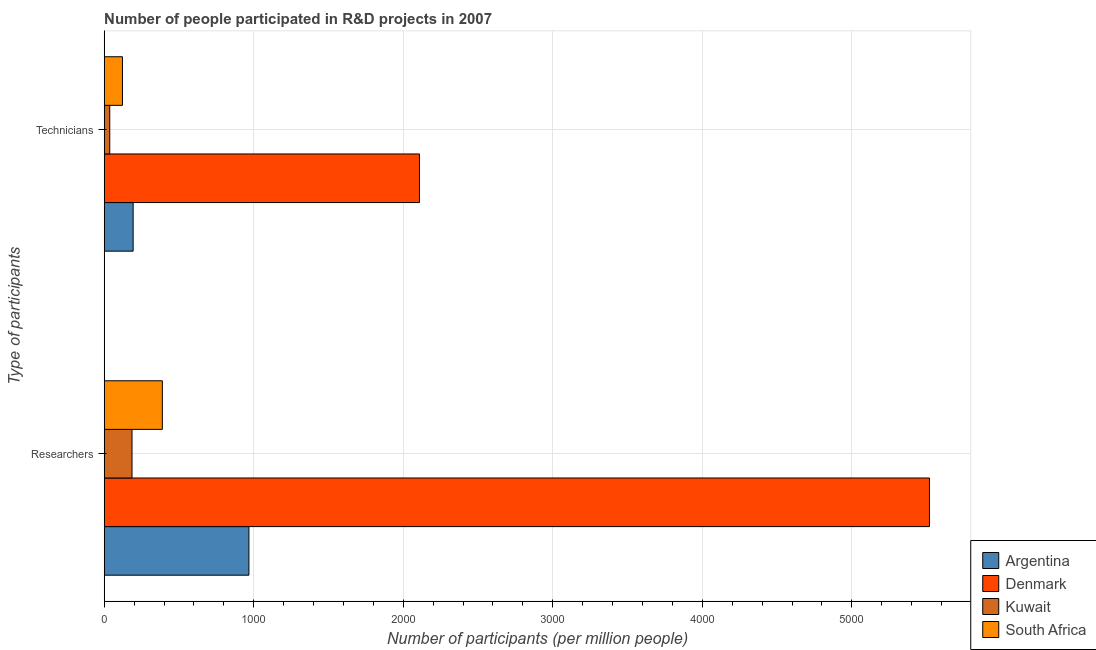How many groups of bars are there?
Your answer should be compact. 2. Are the number of bars per tick equal to the number of legend labels?
Your response must be concise. Yes. How many bars are there on the 2nd tick from the bottom?
Provide a short and direct response. 4. What is the label of the 2nd group of bars from the top?
Your answer should be compact. Researchers. What is the number of technicians in South Africa?
Make the answer very short. 121.96. Across all countries, what is the maximum number of technicians?
Your answer should be compact. 2108.42. Across all countries, what is the minimum number of researchers?
Provide a succinct answer. 185.93. In which country was the number of technicians minimum?
Offer a terse response. Kuwait. What is the total number of researchers in the graph?
Your answer should be compact. 7061.79. What is the difference between the number of researchers in South Africa and that in Kuwait?
Your response must be concise. 202.86. What is the difference between the number of researchers in Argentina and the number of technicians in South Africa?
Provide a short and direct response. 845.8. What is the average number of researchers per country?
Your response must be concise. 1765.45. What is the difference between the number of researchers and number of technicians in Denmark?
Keep it short and to the point. 3410.89. In how many countries, is the number of researchers greater than 3800 ?
Offer a very short reply. 1. What is the ratio of the number of researchers in Denmark to that in South Africa?
Your response must be concise. 14.2. In how many countries, is the number of researchers greater than the average number of researchers taken over all countries?
Your answer should be compact. 1. What does the 1st bar from the top in Researchers represents?
Make the answer very short. South Africa. What does the 4th bar from the bottom in Researchers represents?
Your answer should be very brief. South Africa. How many bars are there?
Your response must be concise. 8. Are all the bars in the graph horizontal?
Your answer should be compact. Yes. How many countries are there in the graph?
Offer a terse response. 4. Does the graph contain grids?
Offer a terse response. Yes. How many legend labels are there?
Your response must be concise. 4. How are the legend labels stacked?
Give a very brief answer. Vertical. What is the title of the graph?
Keep it short and to the point. Number of people participated in R&D projects in 2007. Does "Latin America(all income levels)" appear as one of the legend labels in the graph?
Your response must be concise. No. What is the label or title of the X-axis?
Provide a succinct answer. Number of participants (per million people). What is the label or title of the Y-axis?
Your response must be concise. Type of participants. What is the Number of participants (per million people) in Argentina in Researchers?
Provide a short and direct response. 967.75. What is the Number of participants (per million people) in Denmark in Researchers?
Your answer should be compact. 5519.32. What is the Number of participants (per million people) of Kuwait in Researchers?
Provide a short and direct response. 185.93. What is the Number of participants (per million people) of South Africa in Researchers?
Offer a very short reply. 388.79. What is the Number of participants (per million people) of Argentina in Technicians?
Offer a terse response. 193.45. What is the Number of participants (per million people) in Denmark in Technicians?
Offer a very short reply. 2108.42. What is the Number of participants (per million people) in Kuwait in Technicians?
Ensure brevity in your answer.  37.03. What is the Number of participants (per million people) of South Africa in Technicians?
Your answer should be compact. 121.96. Across all Type of participants, what is the maximum Number of participants (per million people) in Argentina?
Offer a terse response. 967.75. Across all Type of participants, what is the maximum Number of participants (per million people) in Denmark?
Give a very brief answer. 5519.32. Across all Type of participants, what is the maximum Number of participants (per million people) of Kuwait?
Keep it short and to the point. 185.93. Across all Type of participants, what is the maximum Number of participants (per million people) of South Africa?
Provide a succinct answer. 388.79. Across all Type of participants, what is the minimum Number of participants (per million people) of Argentina?
Offer a very short reply. 193.45. Across all Type of participants, what is the minimum Number of participants (per million people) of Denmark?
Your response must be concise. 2108.42. Across all Type of participants, what is the minimum Number of participants (per million people) of Kuwait?
Provide a short and direct response. 37.03. Across all Type of participants, what is the minimum Number of participants (per million people) in South Africa?
Give a very brief answer. 121.96. What is the total Number of participants (per million people) of Argentina in the graph?
Your response must be concise. 1161.2. What is the total Number of participants (per million people) of Denmark in the graph?
Your response must be concise. 7627.74. What is the total Number of participants (per million people) of Kuwait in the graph?
Your answer should be very brief. 222.96. What is the total Number of participants (per million people) in South Africa in the graph?
Give a very brief answer. 510.74. What is the difference between the Number of participants (per million people) in Argentina in Researchers and that in Technicians?
Give a very brief answer. 774.31. What is the difference between the Number of participants (per million people) of Denmark in Researchers and that in Technicians?
Give a very brief answer. 3410.89. What is the difference between the Number of participants (per million people) in Kuwait in Researchers and that in Technicians?
Offer a terse response. 148.9. What is the difference between the Number of participants (per million people) in South Africa in Researchers and that in Technicians?
Provide a short and direct response. 266.83. What is the difference between the Number of participants (per million people) of Argentina in Researchers and the Number of participants (per million people) of Denmark in Technicians?
Offer a very short reply. -1140.67. What is the difference between the Number of participants (per million people) of Argentina in Researchers and the Number of participants (per million people) of Kuwait in Technicians?
Your answer should be very brief. 930.72. What is the difference between the Number of participants (per million people) in Argentina in Researchers and the Number of participants (per million people) in South Africa in Technicians?
Provide a short and direct response. 845.8. What is the difference between the Number of participants (per million people) of Denmark in Researchers and the Number of participants (per million people) of Kuwait in Technicians?
Provide a succinct answer. 5482.29. What is the difference between the Number of participants (per million people) in Denmark in Researchers and the Number of participants (per million people) in South Africa in Technicians?
Ensure brevity in your answer.  5397.36. What is the difference between the Number of participants (per million people) of Kuwait in Researchers and the Number of participants (per million people) of South Africa in Technicians?
Your response must be concise. 63.97. What is the average Number of participants (per million people) in Argentina per Type of participants?
Keep it short and to the point. 580.6. What is the average Number of participants (per million people) in Denmark per Type of participants?
Keep it short and to the point. 3813.87. What is the average Number of participants (per million people) in Kuwait per Type of participants?
Provide a succinct answer. 111.48. What is the average Number of participants (per million people) in South Africa per Type of participants?
Keep it short and to the point. 255.37. What is the difference between the Number of participants (per million people) of Argentina and Number of participants (per million people) of Denmark in Researchers?
Your answer should be very brief. -4551.56. What is the difference between the Number of participants (per million people) in Argentina and Number of participants (per million people) in Kuwait in Researchers?
Your response must be concise. 781.82. What is the difference between the Number of participants (per million people) in Argentina and Number of participants (per million people) in South Africa in Researchers?
Your answer should be very brief. 578.96. What is the difference between the Number of participants (per million people) of Denmark and Number of participants (per million people) of Kuwait in Researchers?
Provide a short and direct response. 5333.39. What is the difference between the Number of participants (per million people) of Denmark and Number of participants (per million people) of South Africa in Researchers?
Your answer should be compact. 5130.53. What is the difference between the Number of participants (per million people) in Kuwait and Number of participants (per million people) in South Africa in Researchers?
Ensure brevity in your answer.  -202.86. What is the difference between the Number of participants (per million people) in Argentina and Number of participants (per million people) in Denmark in Technicians?
Your answer should be compact. -1914.97. What is the difference between the Number of participants (per million people) in Argentina and Number of participants (per million people) in Kuwait in Technicians?
Provide a succinct answer. 156.42. What is the difference between the Number of participants (per million people) in Argentina and Number of participants (per million people) in South Africa in Technicians?
Your answer should be very brief. 71.49. What is the difference between the Number of participants (per million people) of Denmark and Number of participants (per million people) of Kuwait in Technicians?
Provide a succinct answer. 2071.39. What is the difference between the Number of participants (per million people) in Denmark and Number of participants (per million people) in South Africa in Technicians?
Ensure brevity in your answer.  1986.46. What is the difference between the Number of participants (per million people) in Kuwait and Number of participants (per million people) in South Africa in Technicians?
Offer a terse response. -84.93. What is the ratio of the Number of participants (per million people) in Argentina in Researchers to that in Technicians?
Ensure brevity in your answer.  5. What is the ratio of the Number of participants (per million people) in Denmark in Researchers to that in Technicians?
Keep it short and to the point. 2.62. What is the ratio of the Number of participants (per million people) in Kuwait in Researchers to that in Technicians?
Make the answer very short. 5.02. What is the ratio of the Number of participants (per million people) of South Africa in Researchers to that in Technicians?
Your answer should be very brief. 3.19. What is the difference between the highest and the second highest Number of participants (per million people) of Argentina?
Keep it short and to the point. 774.31. What is the difference between the highest and the second highest Number of participants (per million people) of Denmark?
Ensure brevity in your answer.  3410.89. What is the difference between the highest and the second highest Number of participants (per million people) in Kuwait?
Your response must be concise. 148.9. What is the difference between the highest and the second highest Number of participants (per million people) of South Africa?
Offer a terse response. 266.83. What is the difference between the highest and the lowest Number of participants (per million people) of Argentina?
Keep it short and to the point. 774.31. What is the difference between the highest and the lowest Number of participants (per million people) in Denmark?
Make the answer very short. 3410.89. What is the difference between the highest and the lowest Number of participants (per million people) in Kuwait?
Make the answer very short. 148.9. What is the difference between the highest and the lowest Number of participants (per million people) of South Africa?
Offer a terse response. 266.83. 